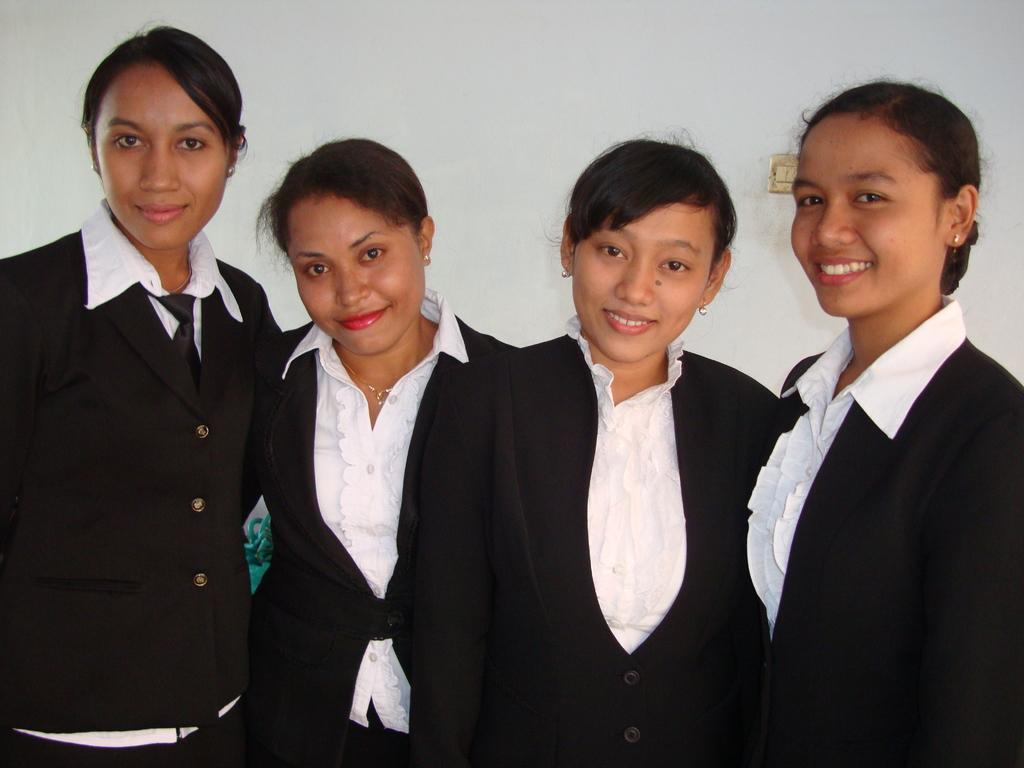How many people are in the image? There are four ladies in the image. What are the ladies doing in the image? The ladies are standing and smiling. What can be seen in the background of the image? There is a wall in the background of the image. What type of lock can be seen on the wall in the image? There is no lock visible on the wall in the image. How many girls are present in the image? The image features four ladies, but it does not specify their gender, so we cannot definitively say if any of them are girls. 